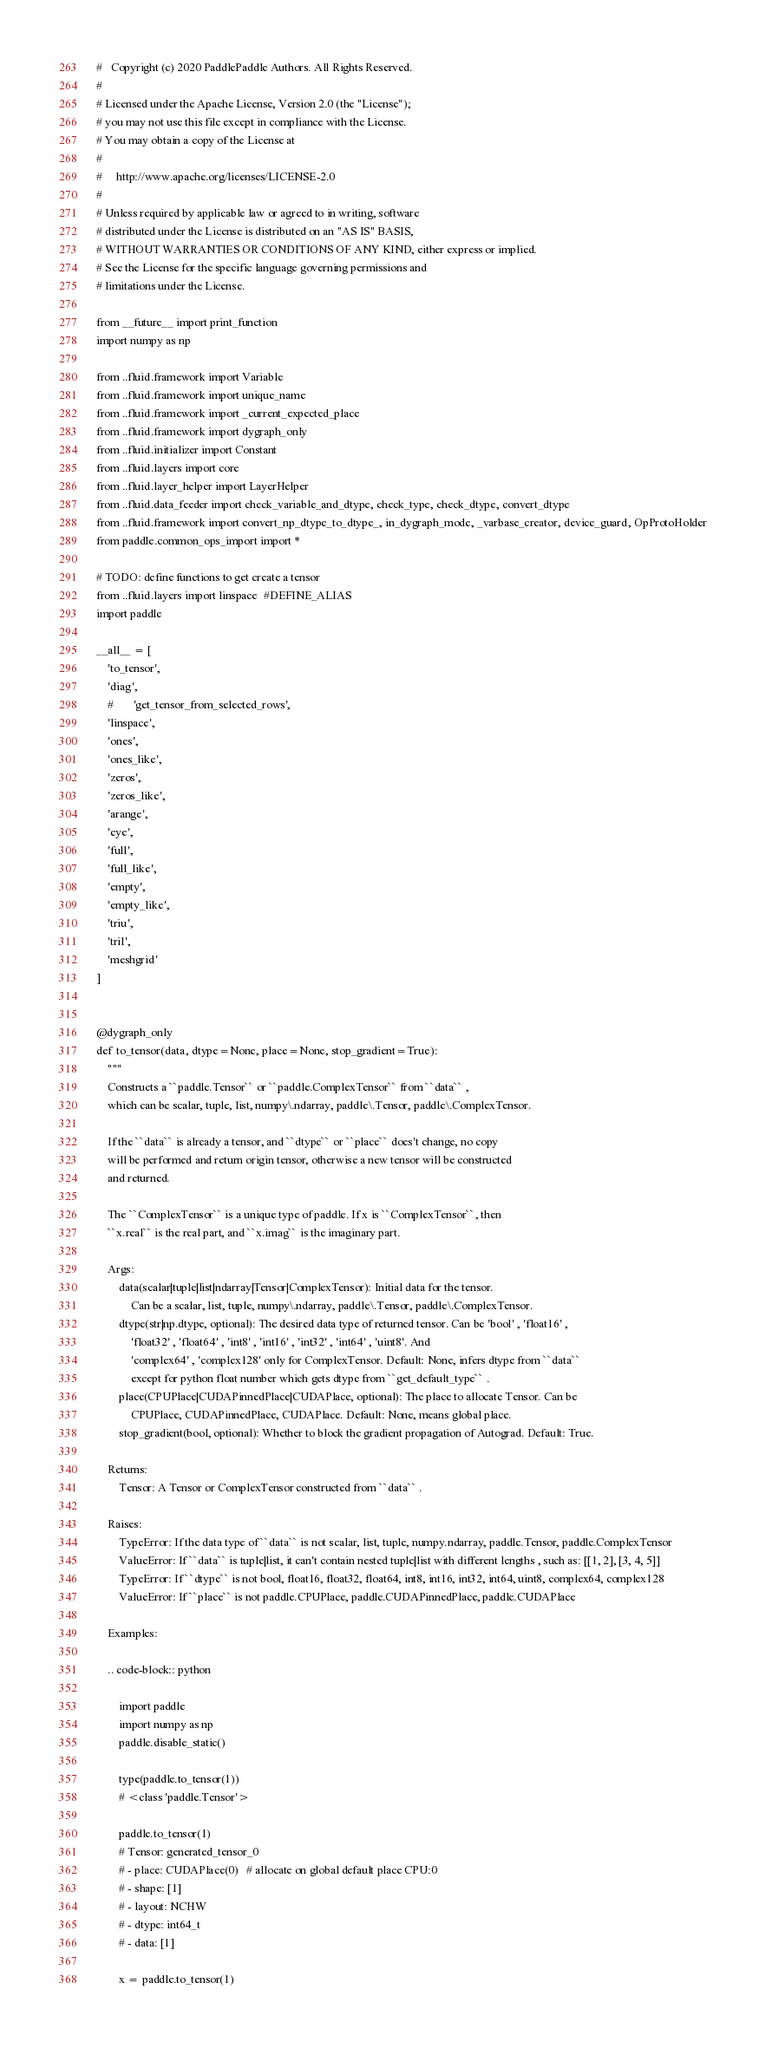Convert code to text. <code><loc_0><loc_0><loc_500><loc_500><_Python_>#   Copyright (c) 2020 PaddlePaddle Authors. All Rights Reserved.
#
# Licensed under the Apache License, Version 2.0 (the "License");
# you may not use this file except in compliance with the License.
# You may obtain a copy of the License at
#
#     http://www.apache.org/licenses/LICENSE-2.0
#
# Unless required by applicable law or agreed to in writing, software
# distributed under the License is distributed on an "AS IS" BASIS,
# WITHOUT WARRANTIES OR CONDITIONS OF ANY KIND, either express or implied.
# See the License for the specific language governing permissions and
# limitations under the License.

from __future__ import print_function
import numpy as np

from ..fluid.framework import Variable
from ..fluid.framework import unique_name
from ..fluid.framework import _current_expected_place
from ..fluid.framework import dygraph_only
from ..fluid.initializer import Constant
from ..fluid.layers import core
from ..fluid.layer_helper import LayerHelper
from ..fluid.data_feeder import check_variable_and_dtype, check_type, check_dtype, convert_dtype
from ..fluid.framework import convert_np_dtype_to_dtype_, in_dygraph_mode, _varbase_creator, device_guard, OpProtoHolder
from paddle.common_ops_import import *

# TODO: define functions to get create a tensor  
from ..fluid.layers import linspace  #DEFINE_ALIAS
import paddle

__all__ = [
    'to_tensor',
    'diag',
    #       'get_tensor_from_selected_rows',
    'linspace',
    'ones',
    'ones_like',
    'zeros',
    'zeros_like',
    'arange',
    'eye',
    'full',
    'full_like',
    'empty',
    'empty_like',
    'triu',
    'tril',
    'meshgrid'
]


@dygraph_only
def to_tensor(data, dtype=None, place=None, stop_gradient=True):
    """
    Constructs a ``paddle.Tensor`` or ``paddle.ComplexTensor`` from ``data`` , 
    which can be scalar, tuple, list, numpy\.ndarray, paddle\.Tensor, paddle\.ComplexTensor.

    If the ``data`` is already a tensor, and ``dtype`` or ``place`` does't change, no copy 
    will be performed and return origin tensor, otherwise a new tensor will be constructed
    and returned. 

    The ``ComplexTensor`` is a unique type of paddle. If x is ``ComplexTensor``, then 
    ``x.real`` is the real part, and ``x.imag`` is the imaginary part.

    Args:
        data(scalar|tuple|list|ndarray|Tensor|ComplexTensor): Initial data for the tensor.
            Can be a scalar, list, tuple, numpy\.ndarray, paddle\.Tensor, paddle\.ComplexTensor.
        dtype(str|np.dtype, optional): The desired data type of returned tensor. Can be 'bool' , 'float16' , 
            'float32' , 'float64' , 'int8' , 'int16' , 'int32' , 'int64' , 'uint8'. And
            'complex64' , 'complex128' only for ComplexTensor. Default: None, infers dtype from ``data`` 
            except for python float number which gets dtype from ``get_default_type`` .
        place(CPUPlace|CUDAPinnedPlace|CUDAPlace, optional): The place to allocate Tensor. Can be  
            CPUPlace, CUDAPinnedPlace, CUDAPlace. Default: None, means global place.
        stop_gradient(bool, optional): Whether to block the gradient propagation of Autograd. Default: True.

    Returns:
        Tensor: A Tensor or ComplexTensor constructed from ``data`` .

    Raises:
        TypeError: If the data type of ``data`` is not scalar, list, tuple, numpy.ndarray, paddle.Tensor, paddle.ComplexTensor
        ValueError: If ``data`` is tuple|list, it can't contain nested tuple|list with different lengths , such as: [[1, 2], [3, 4, 5]]
        TypeError: If ``dtype`` is not bool, float16, float32, float64, int8, int16, int32, int64, uint8, complex64, complex128
        ValueError: If ``place`` is not paddle.CPUPlace, paddle.CUDAPinnedPlace, paddle.CUDAPlace

    Examples:

    .. code-block:: python

        import paddle
        import numpy as np
        paddle.disable_static()
                
        type(paddle.to_tensor(1))
        # <class 'paddle.Tensor'>

        paddle.to_tensor(1)
        # Tensor: generated_tensor_0
        # - place: CUDAPlace(0)   # allocate on global default place CPU:0
        # - shape: [1]
        # - layout: NCHW
        # - dtype: int64_t
        # - data: [1]

        x = paddle.to_tensor(1)</code> 